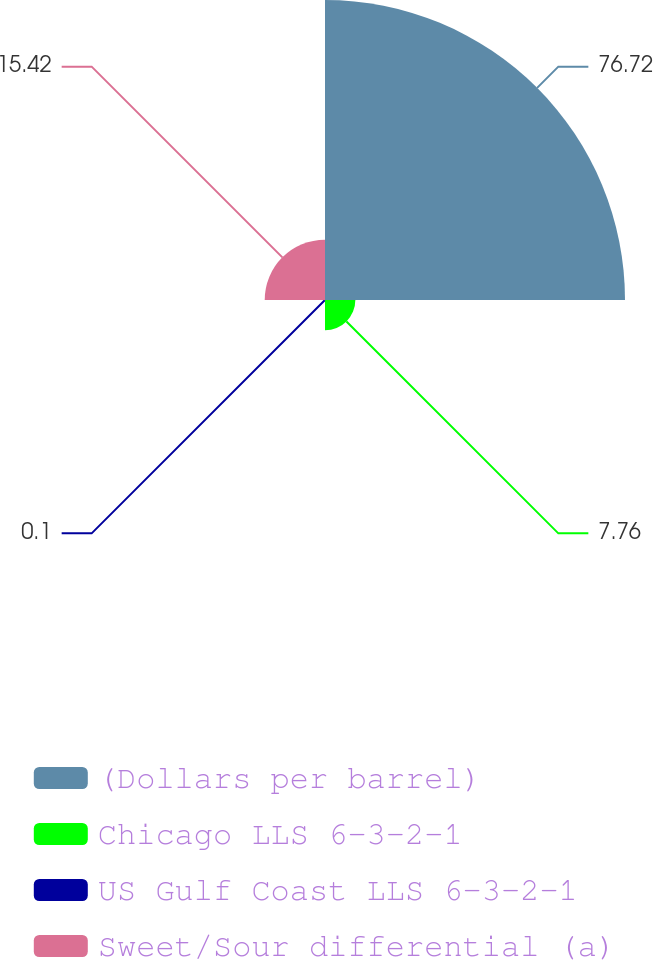Convert chart to OTSL. <chart><loc_0><loc_0><loc_500><loc_500><pie_chart><fcel>(Dollars per barrel)<fcel>Chicago LLS 6-3-2-1<fcel>US Gulf Coast LLS 6-3-2-1<fcel>Sweet/Sour differential (a)<nl><fcel>76.72%<fcel>7.76%<fcel>0.1%<fcel>15.42%<nl></chart> 